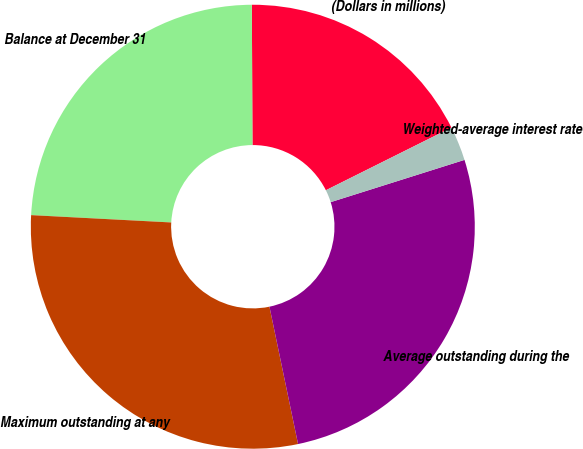Convert chart. <chart><loc_0><loc_0><loc_500><loc_500><pie_chart><fcel>(Dollars in millions)<fcel>Balance at December 31<fcel>Maximum outstanding at any<fcel>Average outstanding during the<fcel>Weighted-average interest rate<nl><fcel>17.7%<fcel>24.1%<fcel>29.1%<fcel>26.6%<fcel>2.5%<nl></chart> 